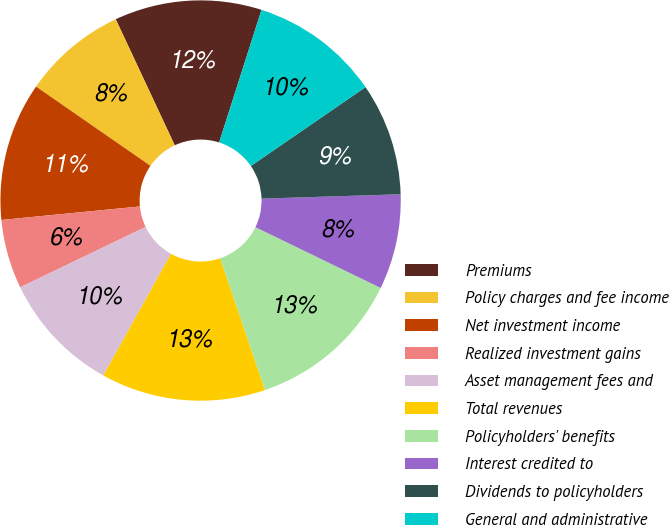<chart> <loc_0><loc_0><loc_500><loc_500><pie_chart><fcel>Premiums<fcel>Policy charges and fee income<fcel>Net investment income<fcel>Realized investment gains<fcel>Asset management fees and<fcel>Total revenues<fcel>Policyholders' benefits<fcel>Interest credited to<fcel>Dividends to policyholders<fcel>General and administrative<nl><fcel>11.89%<fcel>8.39%<fcel>11.19%<fcel>5.59%<fcel>9.79%<fcel>13.29%<fcel>12.59%<fcel>7.69%<fcel>9.09%<fcel>10.49%<nl></chart> 